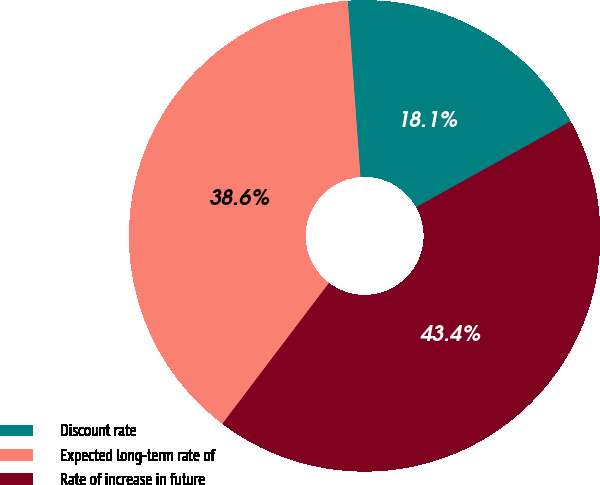Convert chart to OTSL. <chart><loc_0><loc_0><loc_500><loc_500><pie_chart><fcel>Discount rate<fcel>Expected long-term rate of<fcel>Rate of increase in future<nl><fcel>18.07%<fcel>38.55%<fcel>43.37%<nl></chart> 